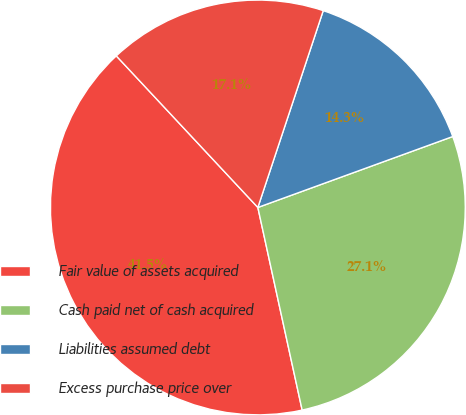<chart> <loc_0><loc_0><loc_500><loc_500><pie_chart><fcel>Fair value of assets acquired<fcel>Cash paid net of cash acquired<fcel>Liabilities assumed debt<fcel>Excess purchase price over<nl><fcel>41.47%<fcel>27.13%<fcel>14.34%<fcel>17.06%<nl></chart> 